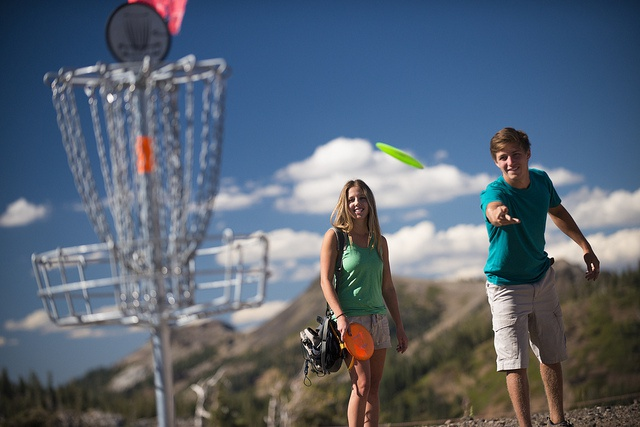Describe the objects in this image and their specific colors. I can see people in black, gray, and lightgray tones, people in black, maroon, darkgreen, and gray tones, handbag in black, gray, darkgray, and lightgray tones, frisbee in black, brown, maroon, and red tones, and frisbee in black, lime, and lightgreen tones in this image. 